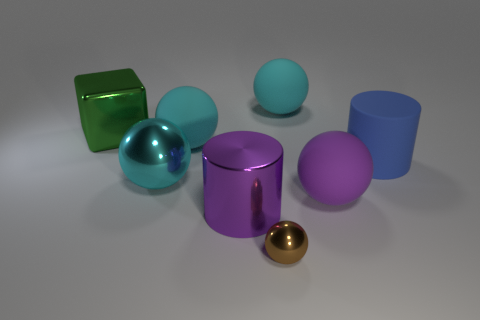Subtract all yellow cubes. How many cyan spheres are left? 3 Subtract 2 spheres. How many spheres are left? 3 Subtract all green balls. Subtract all purple cubes. How many balls are left? 5 Add 1 cyan matte balls. How many objects exist? 9 Subtract all cylinders. How many objects are left? 6 Add 6 big blue cylinders. How many big blue cylinders are left? 7 Add 6 cyan rubber objects. How many cyan rubber objects exist? 8 Subtract 0 red balls. How many objects are left? 8 Subtract all matte balls. Subtract all cyan metal balls. How many objects are left? 4 